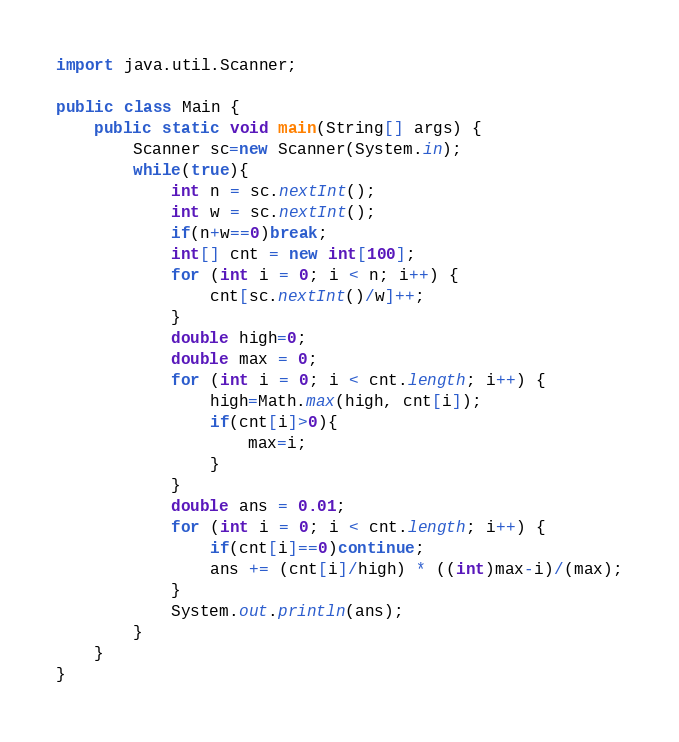Convert code to text. <code><loc_0><loc_0><loc_500><loc_500><_Java_>import java.util.Scanner;

public class Main {
	public static void main(String[] args) {
		Scanner sc=new Scanner(System.in);
		while(true){
			int n = sc.nextInt();
			int w = sc.nextInt();
			if(n+w==0)break;
			int[] cnt = new int[100];
			for (int i = 0; i < n; i++) {
				cnt[sc.nextInt()/w]++;
			}
			double high=0;
			double max = 0;
			for (int i = 0; i < cnt.length; i++) {
				high=Math.max(high, cnt[i]);
				if(cnt[i]>0){
					max=i;
				}
			}
			double ans = 0.01;
			for (int i = 0; i < cnt.length; i++) {
				if(cnt[i]==0)continue;
				ans += (cnt[i]/high) * ((int)max-i)/(max);
			}
			System.out.println(ans);
		}
	}
}</code> 